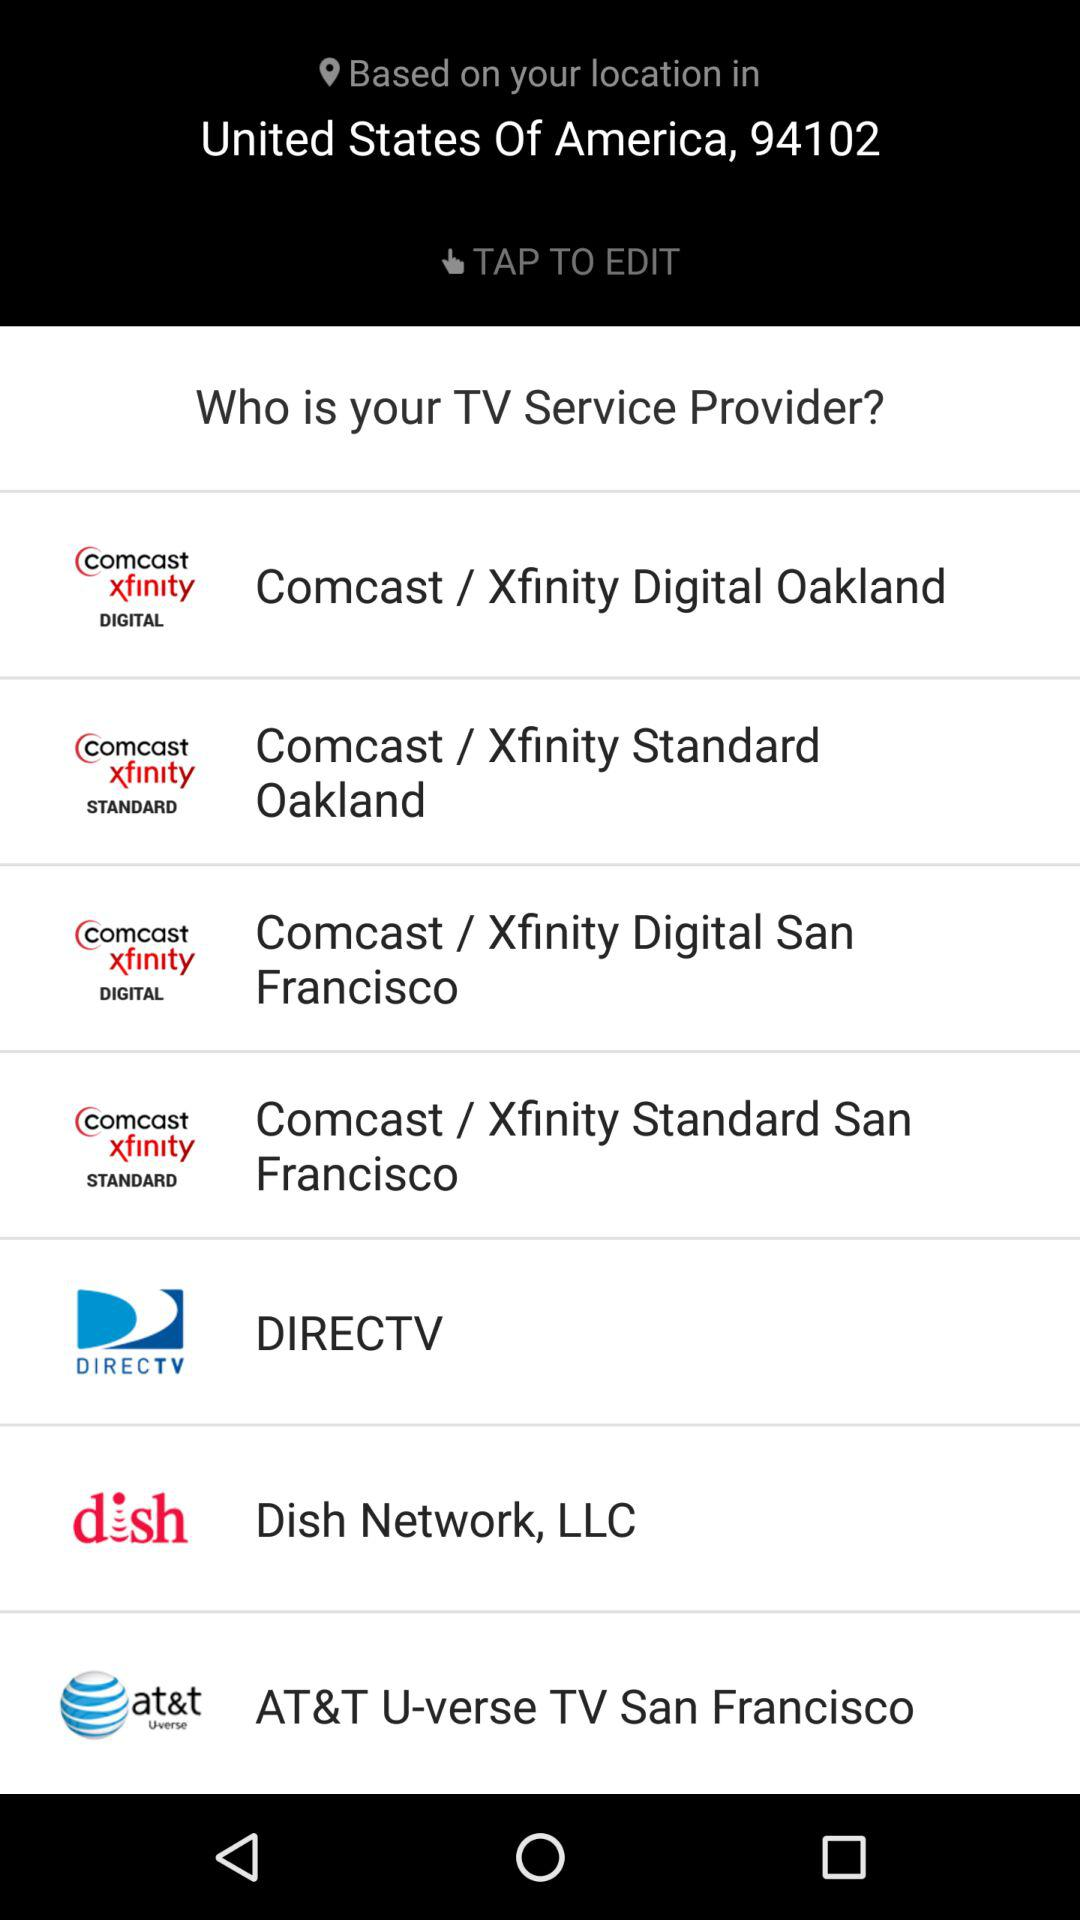How many service providers are offered in Oakland?
Answer the question using a single word or phrase. 2 